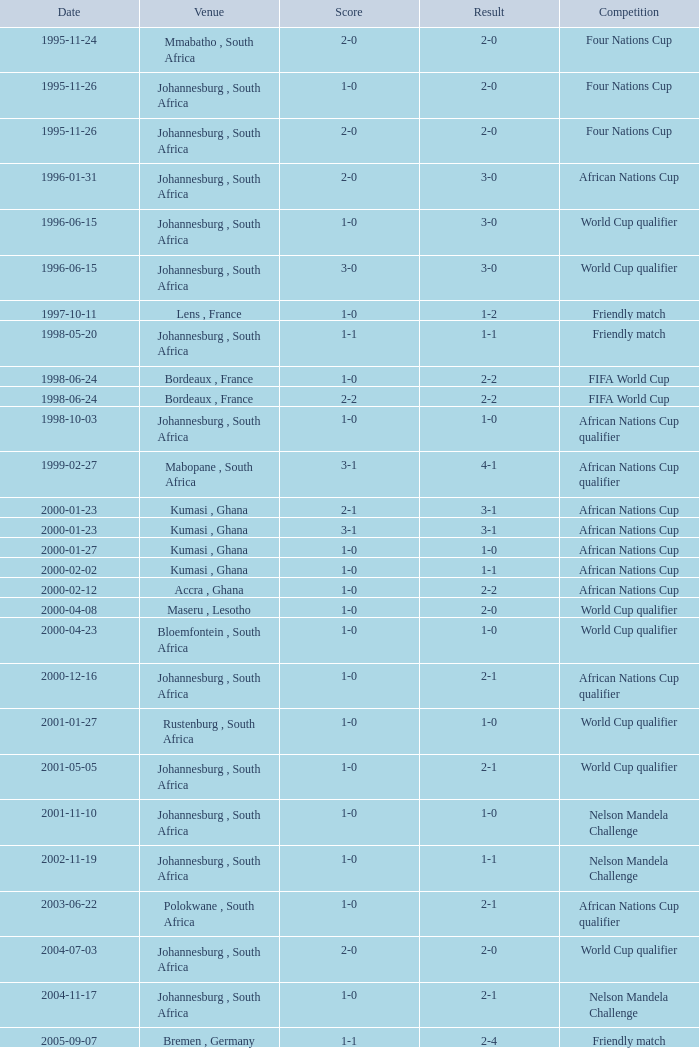What is the Venue of the Competition on 2001-05-05? Johannesburg , South Africa. 